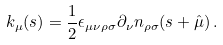<formula> <loc_0><loc_0><loc_500><loc_500>k _ { \mu } ( s ) = \frac { 1 } { 2 } \epsilon _ { \mu \nu \rho \sigma } \partial _ { \nu } n _ { \rho \sigma } ( s + \hat { \mu } ) \, .</formula> 